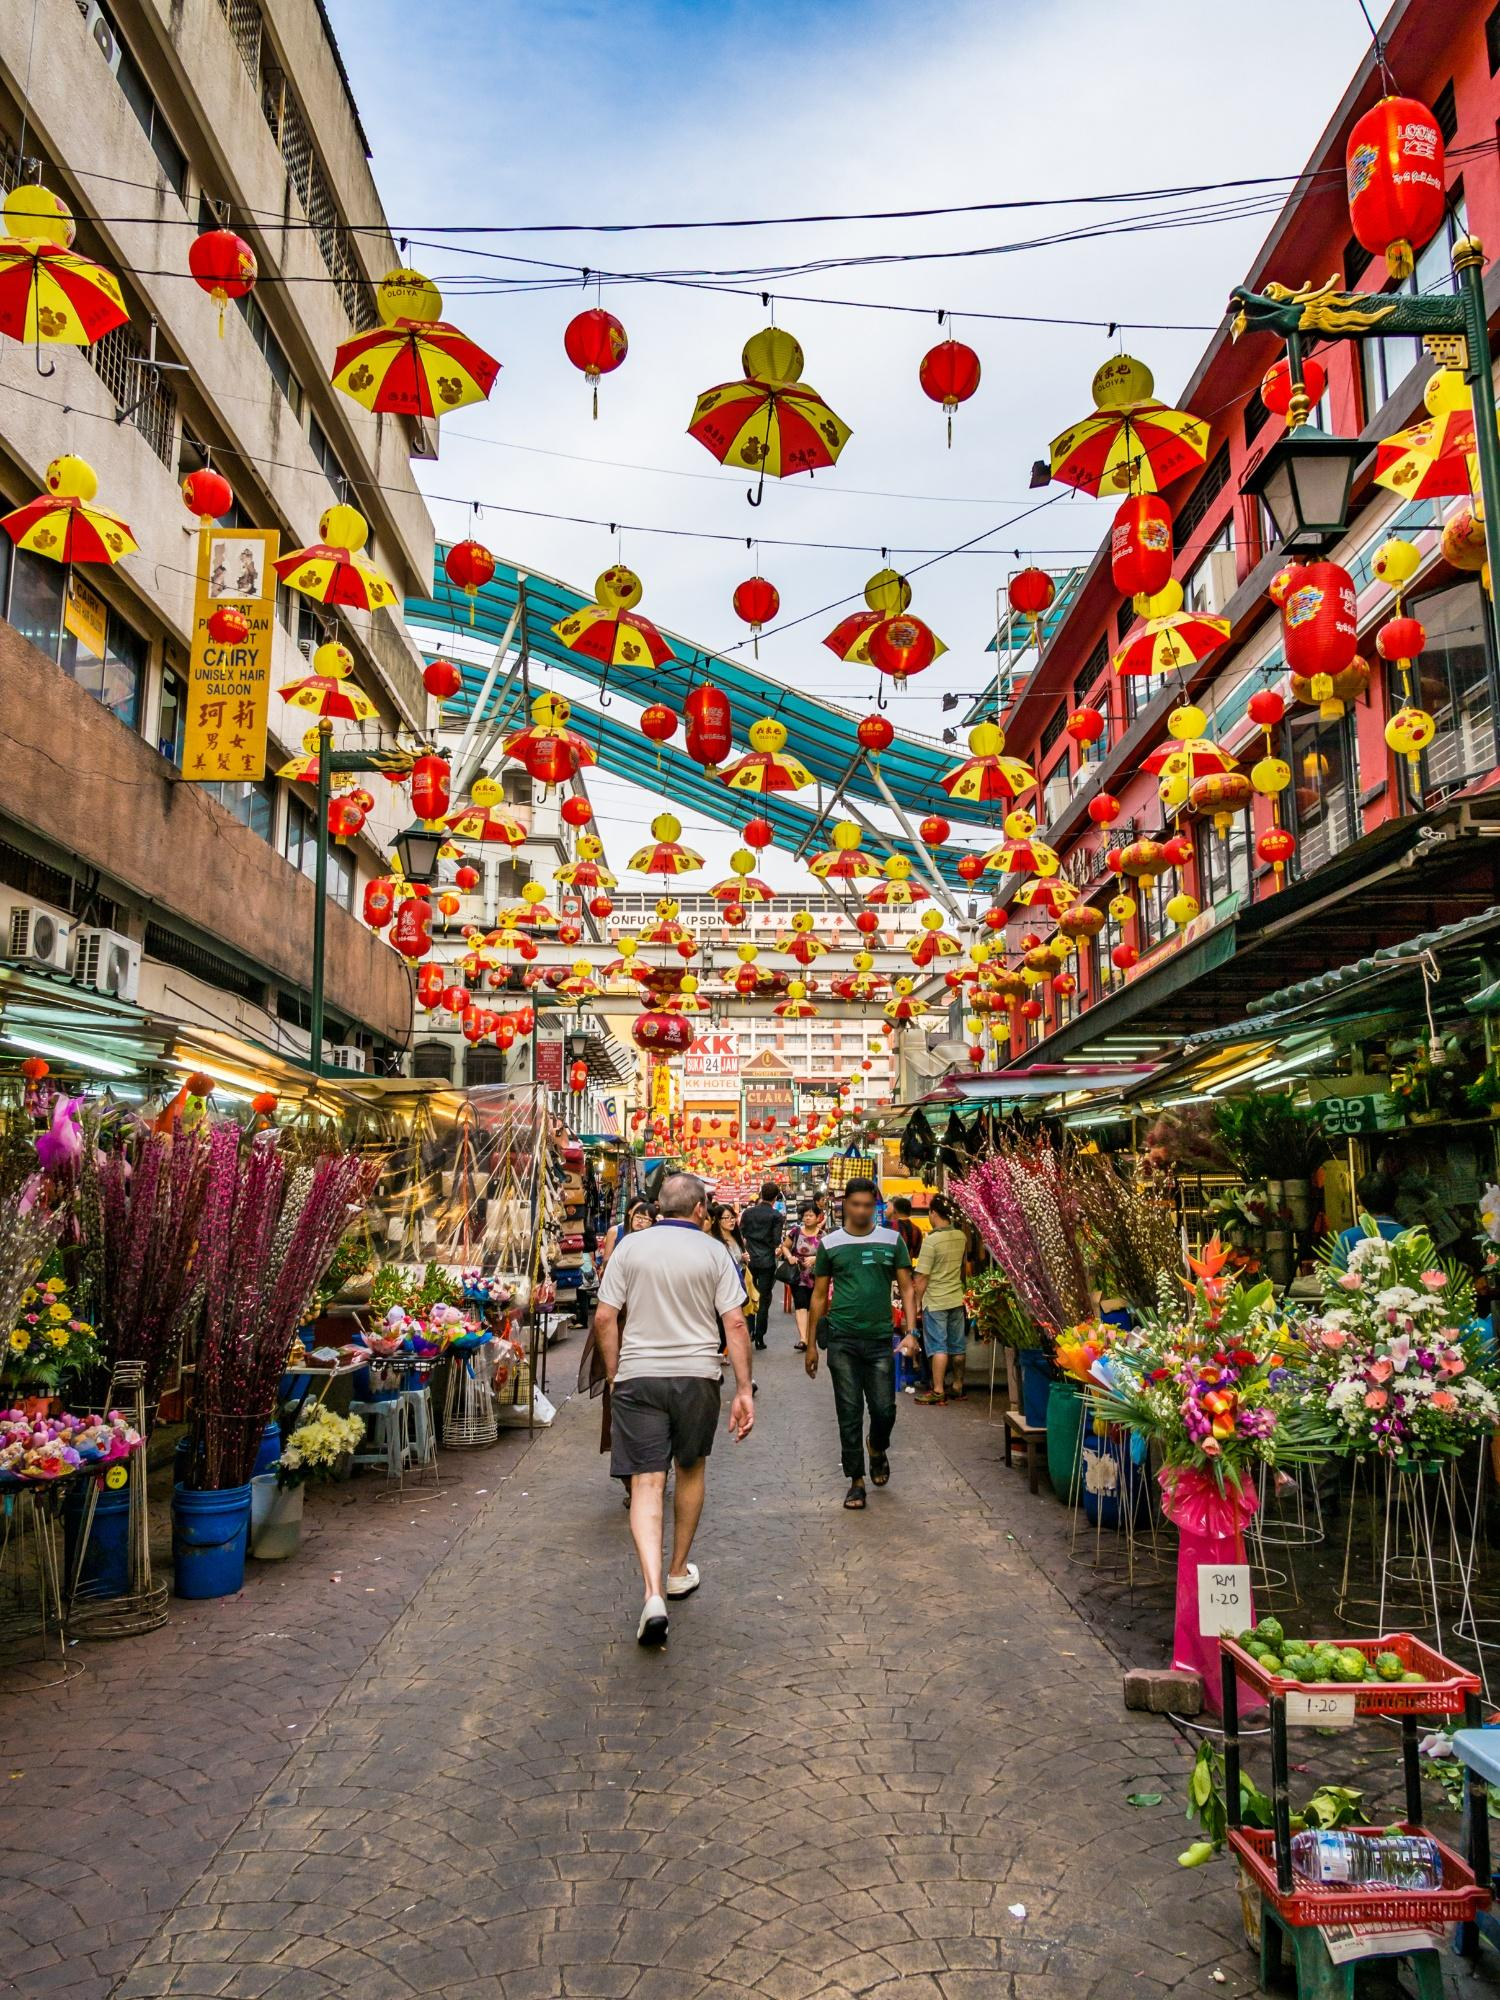How might this scene look in the distant past, say 50 years ago? Fifty years ago, this street likely carried a different character, yet still bustling with activity. The buildings may have been older, showcasing architectural styles from an earlier era. The street might have been narrower, with fewer modern signboards and a more rustic charm. Vendor stalls would have been more simplistic, with goods laid out on wooden tables or even directly on the ground. Instead of vibrant plastic decorations, you might have seen simple cloth awnings and handmade paper lanterns.

The crowd would primarily consist of locals, engaging in barter trade or purchasing daily necessities. The air would be filled with the sounds of hand-pulled carts and street hawkers calling out their wares. Despite technological and commercial advancements, the essence of a lively market, the rich cultural heritage, and the communal atmosphere would be wonderfully preserved in this scene from the past. 